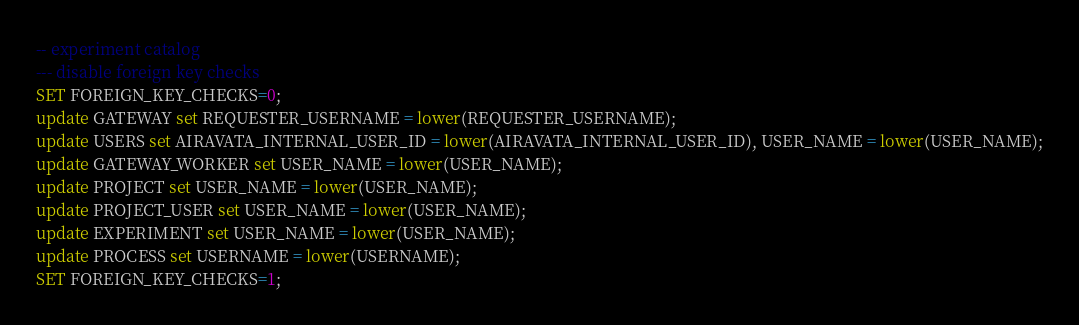Convert code to text. <code><loc_0><loc_0><loc_500><loc_500><_SQL_>-- experiment catalog
--- disable foreign key checks
SET FOREIGN_KEY_CHECKS=0;
update GATEWAY set REQUESTER_USERNAME = lower(REQUESTER_USERNAME);
update USERS set AIRAVATA_INTERNAL_USER_ID = lower(AIRAVATA_INTERNAL_USER_ID), USER_NAME = lower(USER_NAME);
update GATEWAY_WORKER set USER_NAME = lower(USER_NAME);
update PROJECT set USER_NAME = lower(USER_NAME);
update PROJECT_USER set USER_NAME = lower(USER_NAME);
update EXPERIMENT set USER_NAME = lower(USER_NAME);
update PROCESS set USERNAME = lower(USERNAME);
SET FOREIGN_KEY_CHECKS=1;</code> 